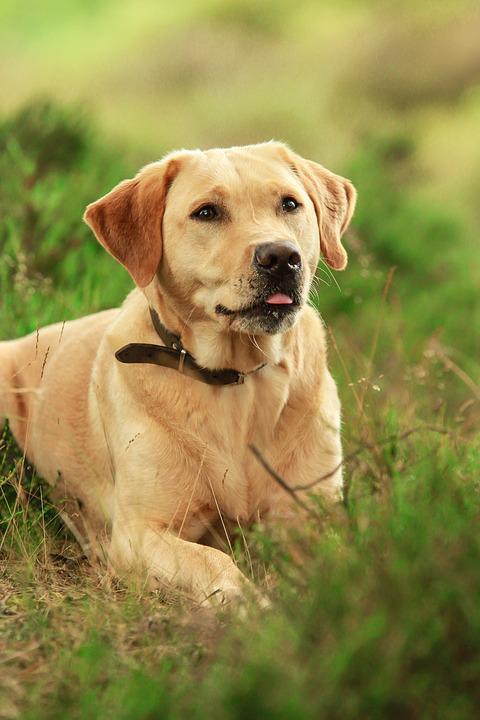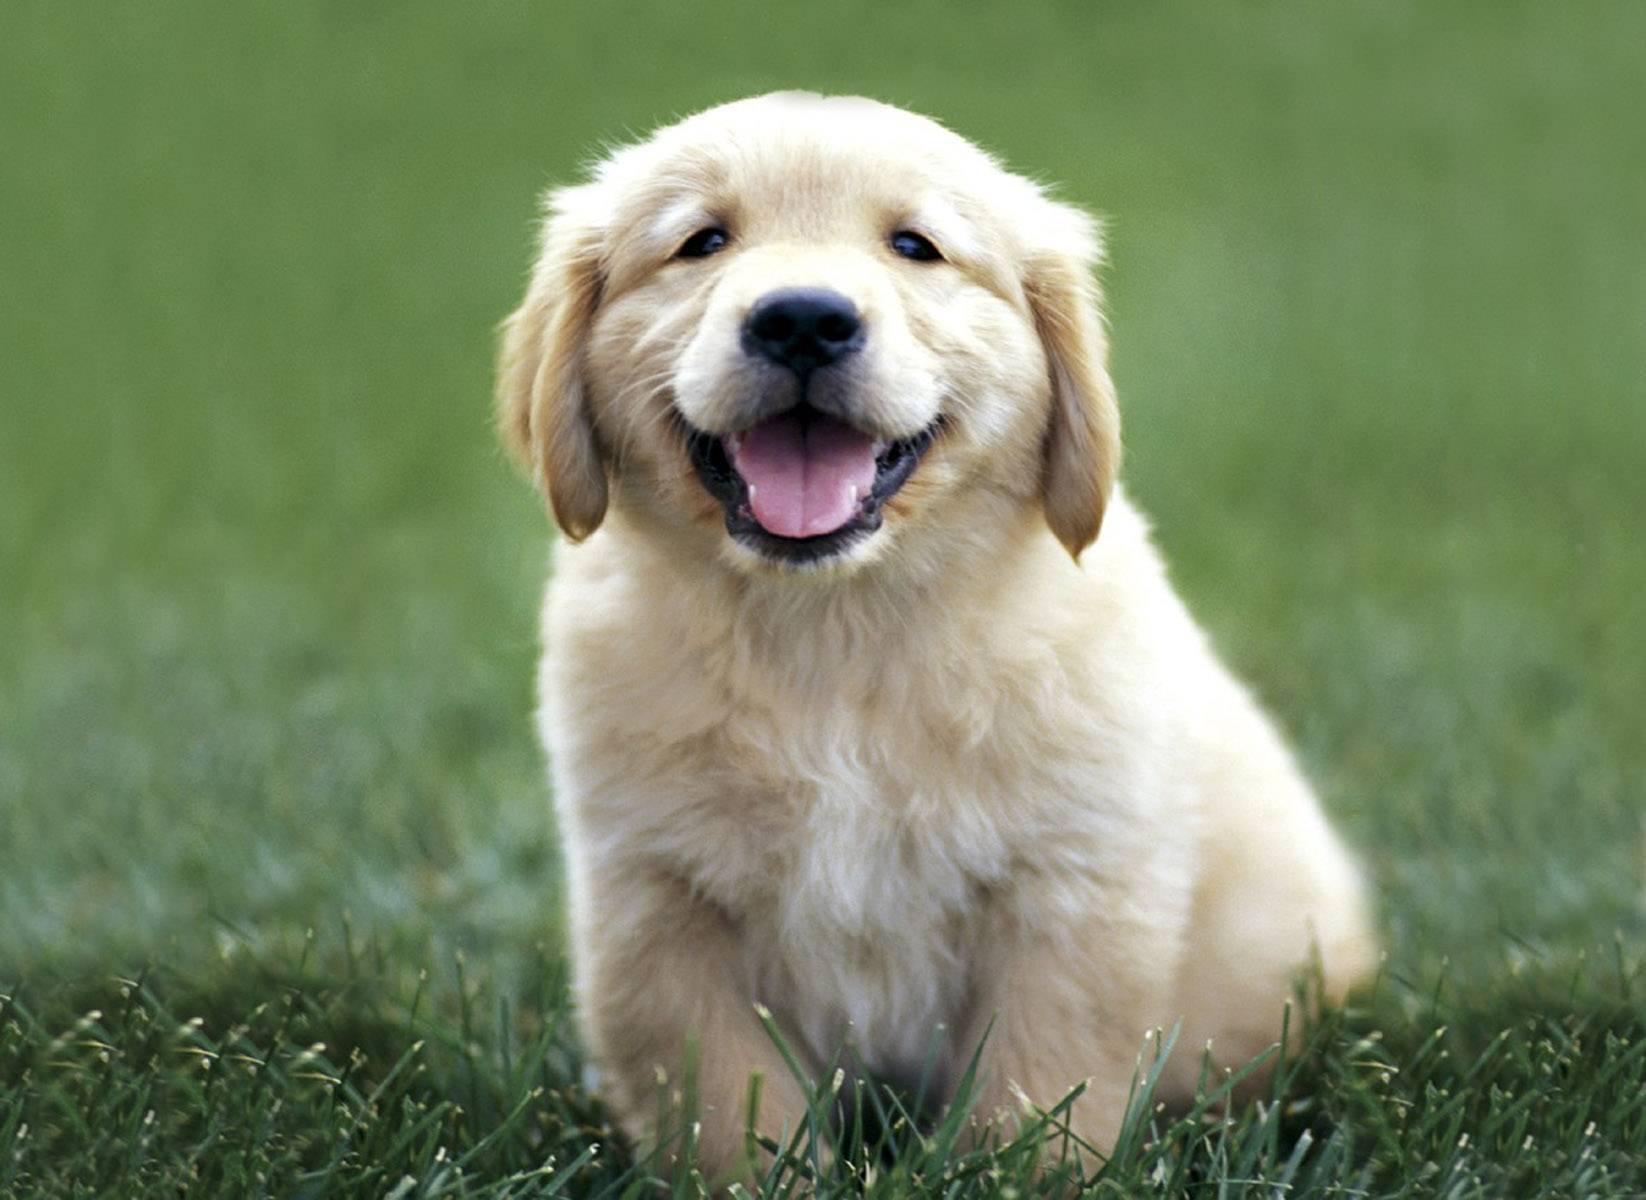The first image is the image on the left, the second image is the image on the right. For the images shown, is this caption "the dog on the right image has its mouth open" true? Answer yes or no. Yes. 